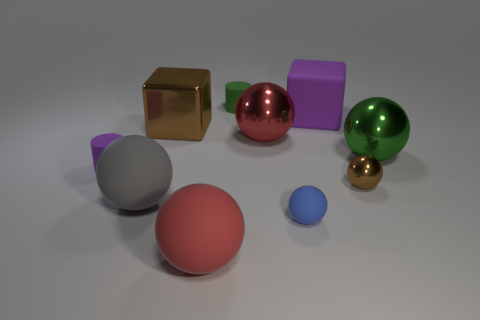Subtract all brown spheres. How many spheres are left? 5 Subtract all big red matte balls. How many balls are left? 5 Subtract all brown balls. Subtract all gray blocks. How many balls are left? 5 Subtract all cubes. How many objects are left? 8 Subtract all tiny cyan shiny cylinders. Subtract all rubber balls. How many objects are left? 7 Add 3 large rubber blocks. How many large rubber blocks are left? 4 Add 7 gray matte spheres. How many gray matte spheres exist? 8 Subtract 0 brown cylinders. How many objects are left? 10 